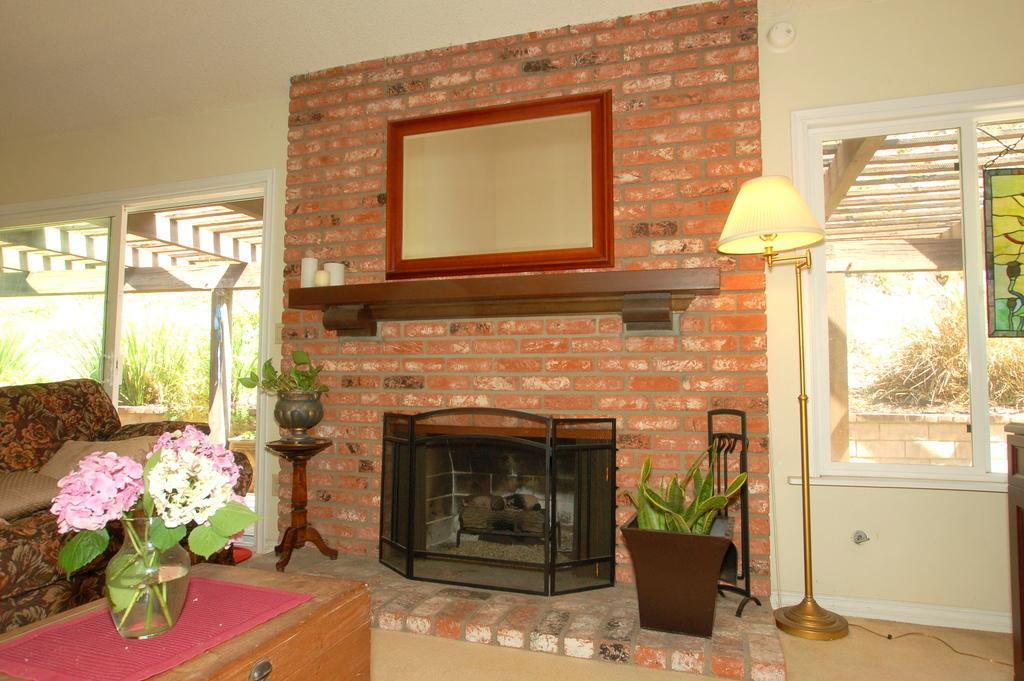Please provide a concise description of this image. In this picture I can observe a fireplace in the middle of the picture. On the left side I can observe a flower vase placed on the table. On the right side I can observe a lamp. In the background there is a wall. On the left side I can observe some plants. 